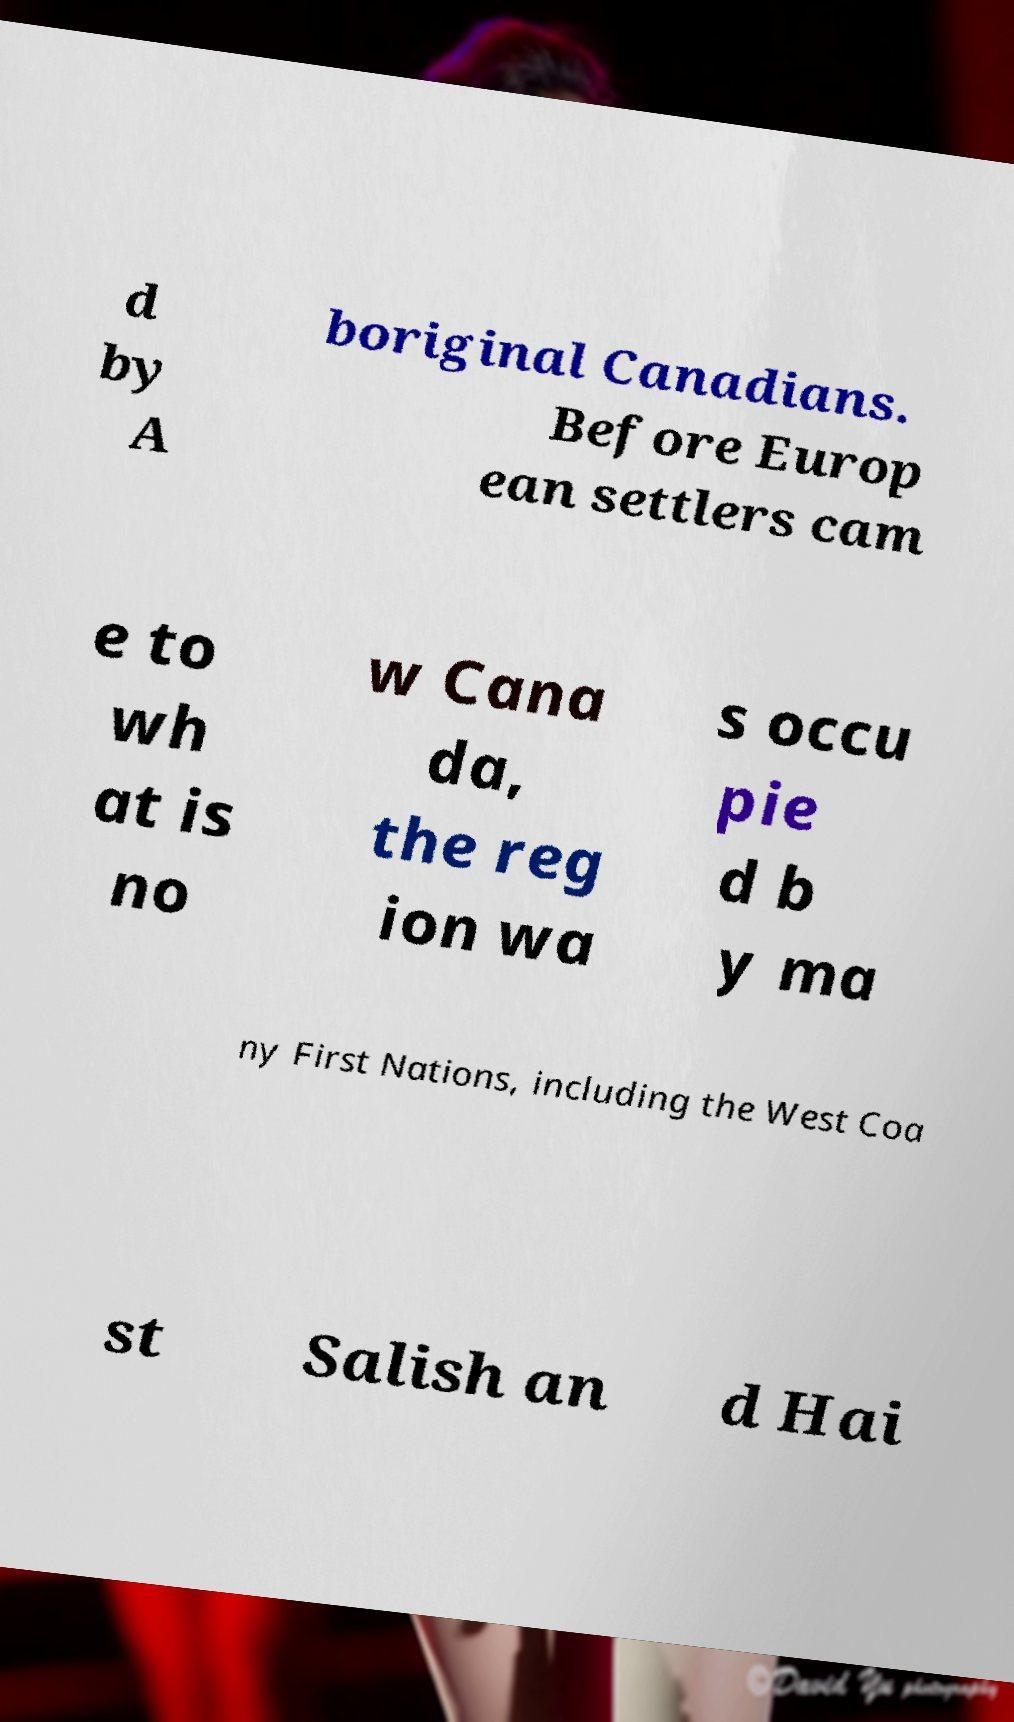Please identify and transcribe the text found in this image. d by A boriginal Canadians. Before Europ ean settlers cam e to wh at is no w Cana da, the reg ion wa s occu pie d b y ma ny First Nations, including the West Coa st Salish an d Hai 